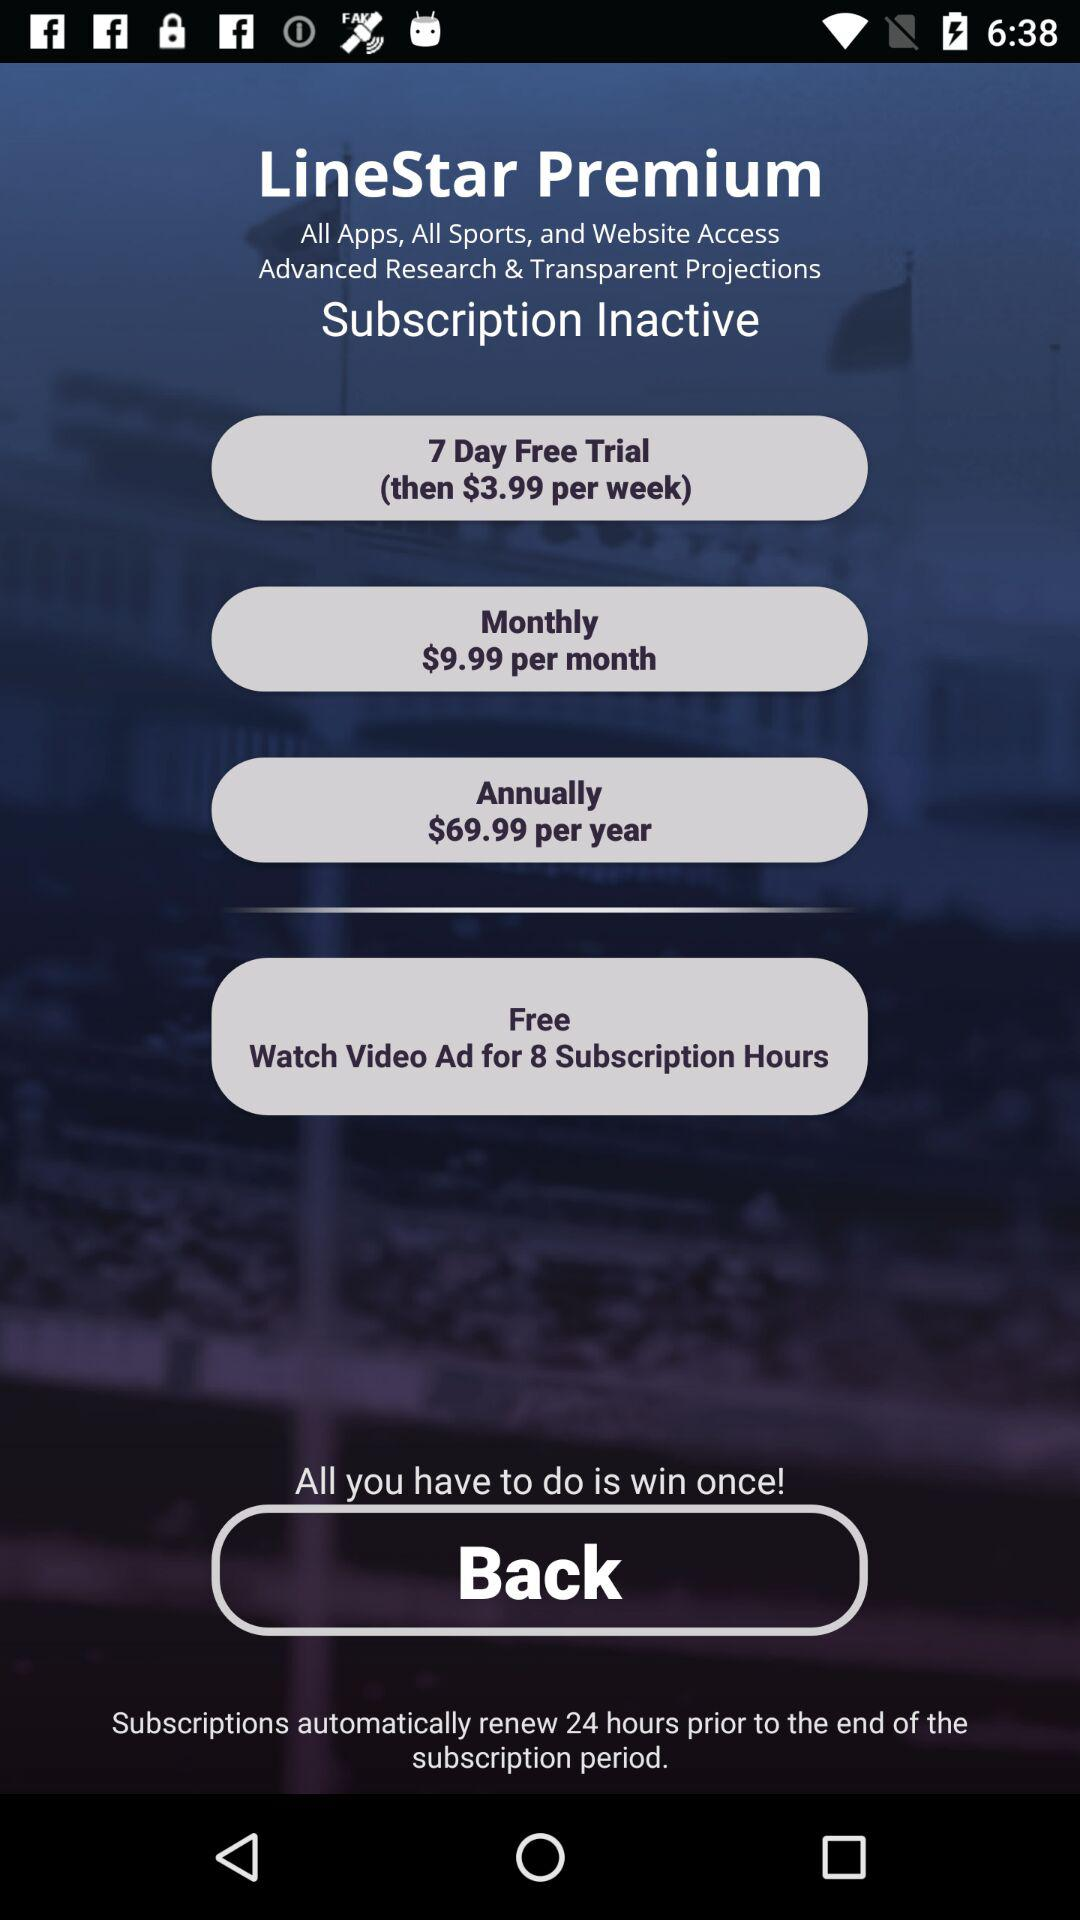What is free for 8 Subscription hours?
When the provided information is insufficient, respond with <no answer>. <no answer> 